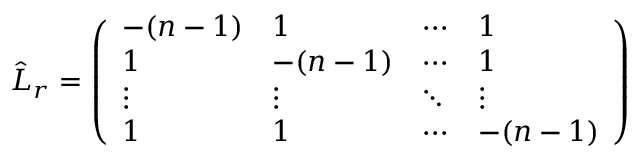<formula> <loc_0><loc_0><loc_500><loc_500>\hat { L } _ { r } = \left ( \begin{array} { l l l l } { - ( n - 1 ) } & { 1 } & { \cdots } & { 1 } \\ { 1 } & { - ( n - 1 ) } & { \cdots } & { 1 } \\ { \vdots } & { \vdots } & { \ddots } & { \vdots } \\ { 1 } & { 1 } & { \cdots } & { - ( n - 1 ) } \end{array} \right )</formula> 